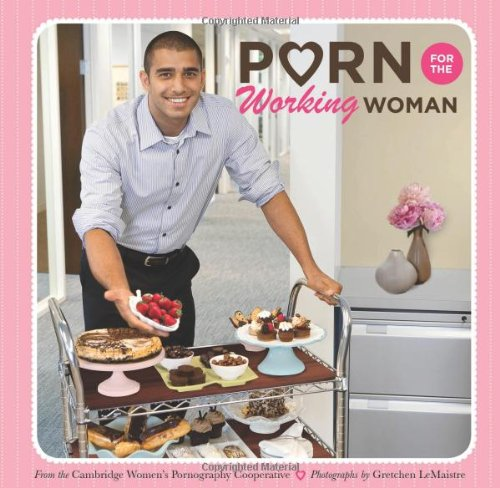What is the title of this book? The title of the book is 'Porn for the Working Woman', which hints at humorous content tailored for women in the workforce. 